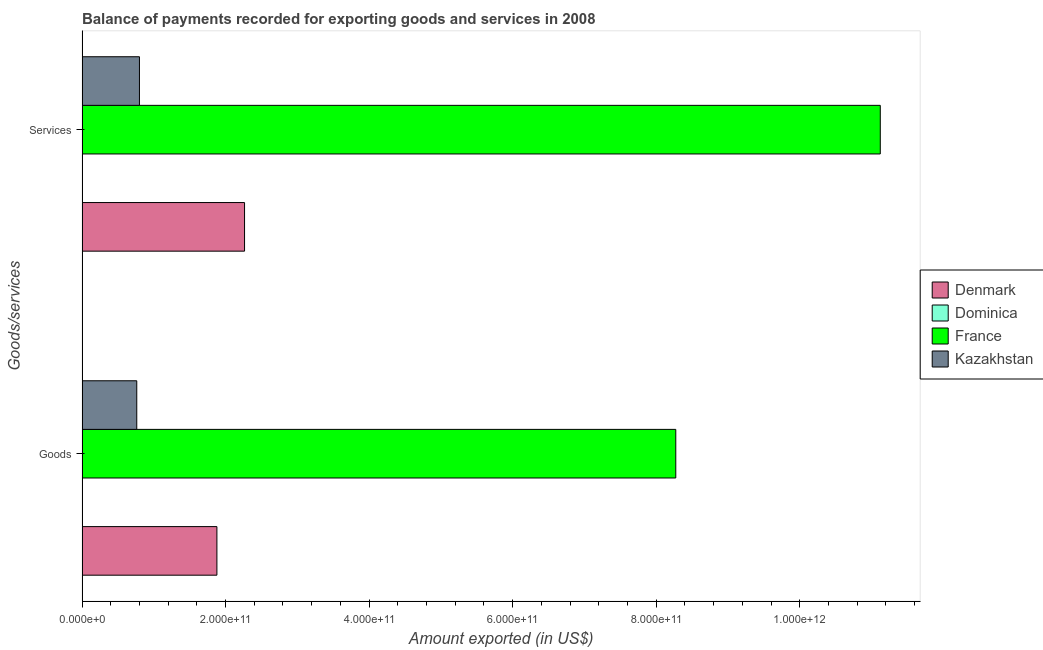How many groups of bars are there?
Provide a short and direct response. 2. How many bars are there on the 1st tick from the bottom?
Provide a short and direct response. 4. What is the label of the 1st group of bars from the top?
Your answer should be very brief. Services. What is the amount of services exported in France?
Keep it short and to the point. 1.11e+12. Across all countries, what is the maximum amount of services exported?
Your response must be concise. 1.11e+12. Across all countries, what is the minimum amount of services exported?
Your answer should be compact. 1.65e+08. In which country was the amount of services exported maximum?
Provide a short and direct response. France. In which country was the amount of goods exported minimum?
Give a very brief answer. Dominica. What is the total amount of services exported in the graph?
Your response must be concise. 1.42e+12. What is the difference between the amount of goods exported in Denmark and that in France?
Offer a very short reply. -6.39e+11. What is the difference between the amount of goods exported in France and the amount of services exported in Dominica?
Provide a short and direct response. 8.27e+11. What is the average amount of goods exported per country?
Give a very brief answer. 2.73e+11. What is the difference between the amount of goods exported and amount of services exported in Denmark?
Ensure brevity in your answer.  -3.85e+1. What is the ratio of the amount of goods exported in Dominica to that in Denmark?
Ensure brevity in your answer.  0. Is the amount of services exported in Dominica less than that in France?
Ensure brevity in your answer.  Yes. What does the 1st bar from the top in Services represents?
Your response must be concise. Kazakhstan. What does the 4th bar from the bottom in Goods represents?
Your response must be concise. Kazakhstan. Are all the bars in the graph horizontal?
Offer a terse response. Yes. What is the difference between two consecutive major ticks on the X-axis?
Your answer should be compact. 2.00e+11. Does the graph contain any zero values?
Offer a terse response. No. Does the graph contain grids?
Your answer should be compact. No. What is the title of the graph?
Offer a terse response. Balance of payments recorded for exporting goods and services in 2008. What is the label or title of the X-axis?
Your answer should be compact. Amount exported (in US$). What is the label or title of the Y-axis?
Give a very brief answer. Goods/services. What is the Amount exported (in US$) in Denmark in Goods?
Your response must be concise. 1.88e+11. What is the Amount exported (in US$) in Dominica in Goods?
Offer a very short reply. 1.57e+08. What is the Amount exported (in US$) in France in Goods?
Ensure brevity in your answer.  8.27e+11. What is the Amount exported (in US$) of Kazakhstan in Goods?
Give a very brief answer. 7.63e+1. What is the Amount exported (in US$) of Denmark in Services?
Give a very brief answer. 2.26e+11. What is the Amount exported (in US$) of Dominica in Services?
Your answer should be compact. 1.65e+08. What is the Amount exported (in US$) of France in Services?
Keep it short and to the point. 1.11e+12. What is the Amount exported (in US$) of Kazakhstan in Services?
Provide a succinct answer. 8.00e+1. Across all Goods/services, what is the maximum Amount exported (in US$) in Denmark?
Your response must be concise. 2.26e+11. Across all Goods/services, what is the maximum Amount exported (in US$) in Dominica?
Keep it short and to the point. 1.65e+08. Across all Goods/services, what is the maximum Amount exported (in US$) of France?
Provide a short and direct response. 1.11e+12. Across all Goods/services, what is the maximum Amount exported (in US$) of Kazakhstan?
Your answer should be very brief. 8.00e+1. Across all Goods/services, what is the minimum Amount exported (in US$) of Denmark?
Provide a short and direct response. 1.88e+11. Across all Goods/services, what is the minimum Amount exported (in US$) in Dominica?
Your response must be concise. 1.57e+08. Across all Goods/services, what is the minimum Amount exported (in US$) of France?
Your response must be concise. 8.27e+11. Across all Goods/services, what is the minimum Amount exported (in US$) in Kazakhstan?
Keep it short and to the point. 7.63e+1. What is the total Amount exported (in US$) in Denmark in the graph?
Provide a succinct answer. 4.14e+11. What is the total Amount exported (in US$) in Dominica in the graph?
Provide a short and direct response. 3.22e+08. What is the total Amount exported (in US$) in France in the graph?
Give a very brief answer. 1.94e+12. What is the total Amount exported (in US$) in Kazakhstan in the graph?
Your answer should be very brief. 1.56e+11. What is the difference between the Amount exported (in US$) of Denmark in Goods and that in Services?
Provide a succinct answer. -3.85e+1. What is the difference between the Amount exported (in US$) of Dominica in Goods and that in Services?
Offer a very short reply. -8.42e+06. What is the difference between the Amount exported (in US$) in France in Goods and that in Services?
Make the answer very short. -2.85e+11. What is the difference between the Amount exported (in US$) of Kazakhstan in Goods and that in Services?
Your answer should be very brief. -3.74e+09. What is the difference between the Amount exported (in US$) in Denmark in Goods and the Amount exported (in US$) in Dominica in Services?
Make the answer very short. 1.88e+11. What is the difference between the Amount exported (in US$) in Denmark in Goods and the Amount exported (in US$) in France in Services?
Your response must be concise. -9.24e+11. What is the difference between the Amount exported (in US$) of Denmark in Goods and the Amount exported (in US$) of Kazakhstan in Services?
Your answer should be very brief. 1.08e+11. What is the difference between the Amount exported (in US$) of Dominica in Goods and the Amount exported (in US$) of France in Services?
Provide a short and direct response. -1.11e+12. What is the difference between the Amount exported (in US$) of Dominica in Goods and the Amount exported (in US$) of Kazakhstan in Services?
Your response must be concise. -7.98e+1. What is the difference between the Amount exported (in US$) in France in Goods and the Amount exported (in US$) in Kazakhstan in Services?
Give a very brief answer. 7.47e+11. What is the average Amount exported (in US$) of Denmark per Goods/services?
Keep it short and to the point. 2.07e+11. What is the average Amount exported (in US$) of Dominica per Goods/services?
Provide a succinct answer. 1.61e+08. What is the average Amount exported (in US$) of France per Goods/services?
Your answer should be very brief. 9.70e+11. What is the average Amount exported (in US$) in Kazakhstan per Goods/services?
Offer a terse response. 7.81e+1. What is the difference between the Amount exported (in US$) in Denmark and Amount exported (in US$) in Dominica in Goods?
Provide a succinct answer. 1.88e+11. What is the difference between the Amount exported (in US$) of Denmark and Amount exported (in US$) of France in Goods?
Your answer should be compact. -6.39e+11. What is the difference between the Amount exported (in US$) of Denmark and Amount exported (in US$) of Kazakhstan in Goods?
Give a very brief answer. 1.12e+11. What is the difference between the Amount exported (in US$) of Dominica and Amount exported (in US$) of France in Goods?
Give a very brief answer. -8.27e+11. What is the difference between the Amount exported (in US$) in Dominica and Amount exported (in US$) in Kazakhstan in Goods?
Offer a terse response. -7.61e+1. What is the difference between the Amount exported (in US$) in France and Amount exported (in US$) in Kazakhstan in Goods?
Offer a very short reply. 7.51e+11. What is the difference between the Amount exported (in US$) in Denmark and Amount exported (in US$) in Dominica in Services?
Provide a succinct answer. 2.26e+11. What is the difference between the Amount exported (in US$) of Denmark and Amount exported (in US$) of France in Services?
Provide a succinct answer. -8.86e+11. What is the difference between the Amount exported (in US$) of Denmark and Amount exported (in US$) of Kazakhstan in Services?
Make the answer very short. 1.46e+11. What is the difference between the Amount exported (in US$) in Dominica and Amount exported (in US$) in France in Services?
Keep it short and to the point. -1.11e+12. What is the difference between the Amount exported (in US$) in Dominica and Amount exported (in US$) in Kazakhstan in Services?
Keep it short and to the point. -7.98e+1. What is the difference between the Amount exported (in US$) of France and Amount exported (in US$) of Kazakhstan in Services?
Make the answer very short. 1.03e+12. What is the ratio of the Amount exported (in US$) in Denmark in Goods to that in Services?
Ensure brevity in your answer.  0.83. What is the ratio of the Amount exported (in US$) in Dominica in Goods to that in Services?
Offer a very short reply. 0.95. What is the ratio of the Amount exported (in US$) in France in Goods to that in Services?
Make the answer very short. 0.74. What is the ratio of the Amount exported (in US$) in Kazakhstan in Goods to that in Services?
Your answer should be compact. 0.95. What is the difference between the highest and the second highest Amount exported (in US$) in Denmark?
Offer a terse response. 3.85e+1. What is the difference between the highest and the second highest Amount exported (in US$) in Dominica?
Your response must be concise. 8.42e+06. What is the difference between the highest and the second highest Amount exported (in US$) in France?
Offer a very short reply. 2.85e+11. What is the difference between the highest and the second highest Amount exported (in US$) of Kazakhstan?
Make the answer very short. 3.74e+09. What is the difference between the highest and the lowest Amount exported (in US$) of Denmark?
Give a very brief answer. 3.85e+1. What is the difference between the highest and the lowest Amount exported (in US$) in Dominica?
Your answer should be very brief. 8.42e+06. What is the difference between the highest and the lowest Amount exported (in US$) of France?
Your answer should be very brief. 2.85e+11. What is the difference between the highest and the lowest Amount exported (in US$) of Kazakhstan?
Offer a terse response. 3.74e+09. 